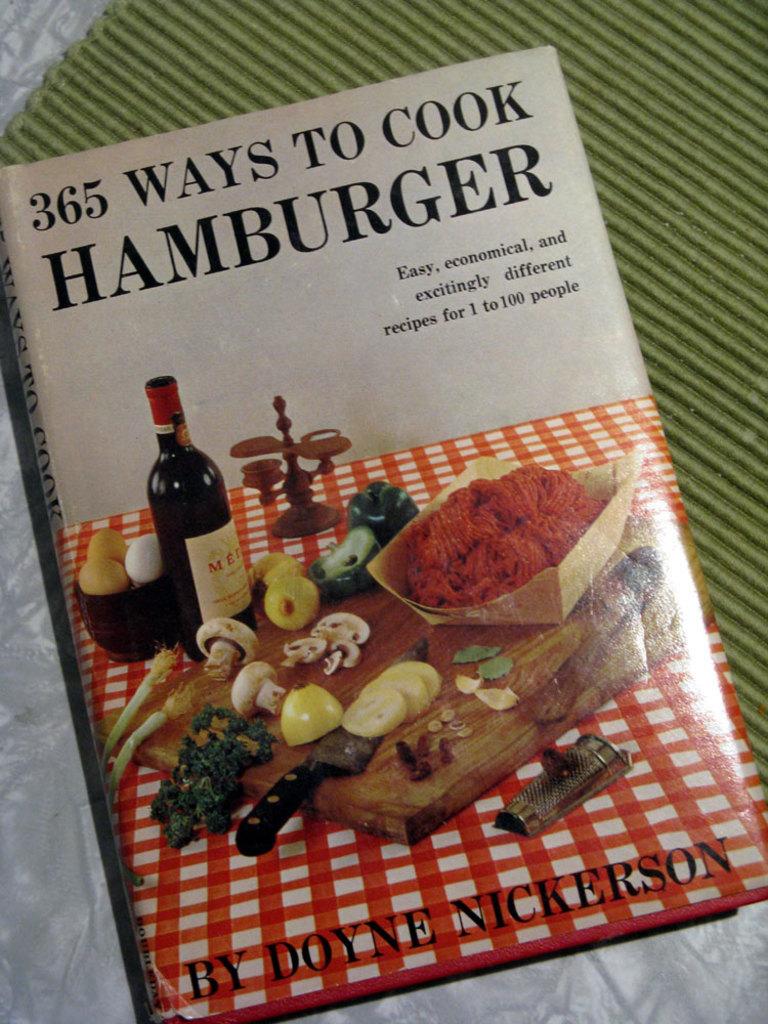What kind of book is this?
Offer a terse response. Cookbook. How many ways to cook?
Ensure brevity in your answer.  365. 